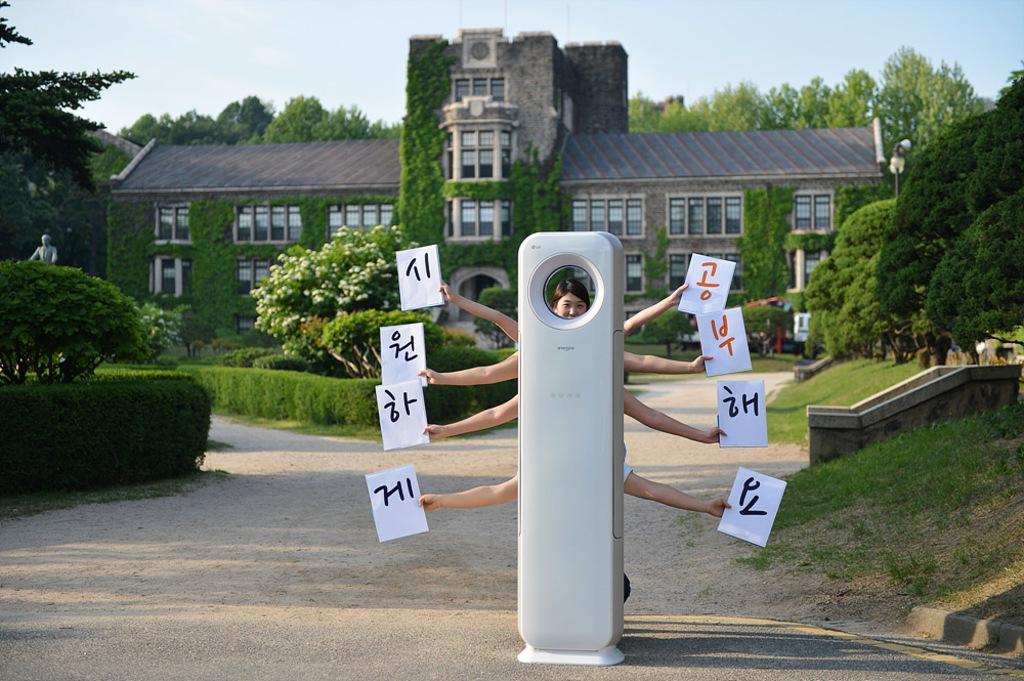In one or two sentences, can you explain what this image depicts? In this image we can see there is an object, behind the object there are a few people standing and holding papers with some text on it, behind them there is a building, around the building there are trees and plants. In the background there is the sky. 